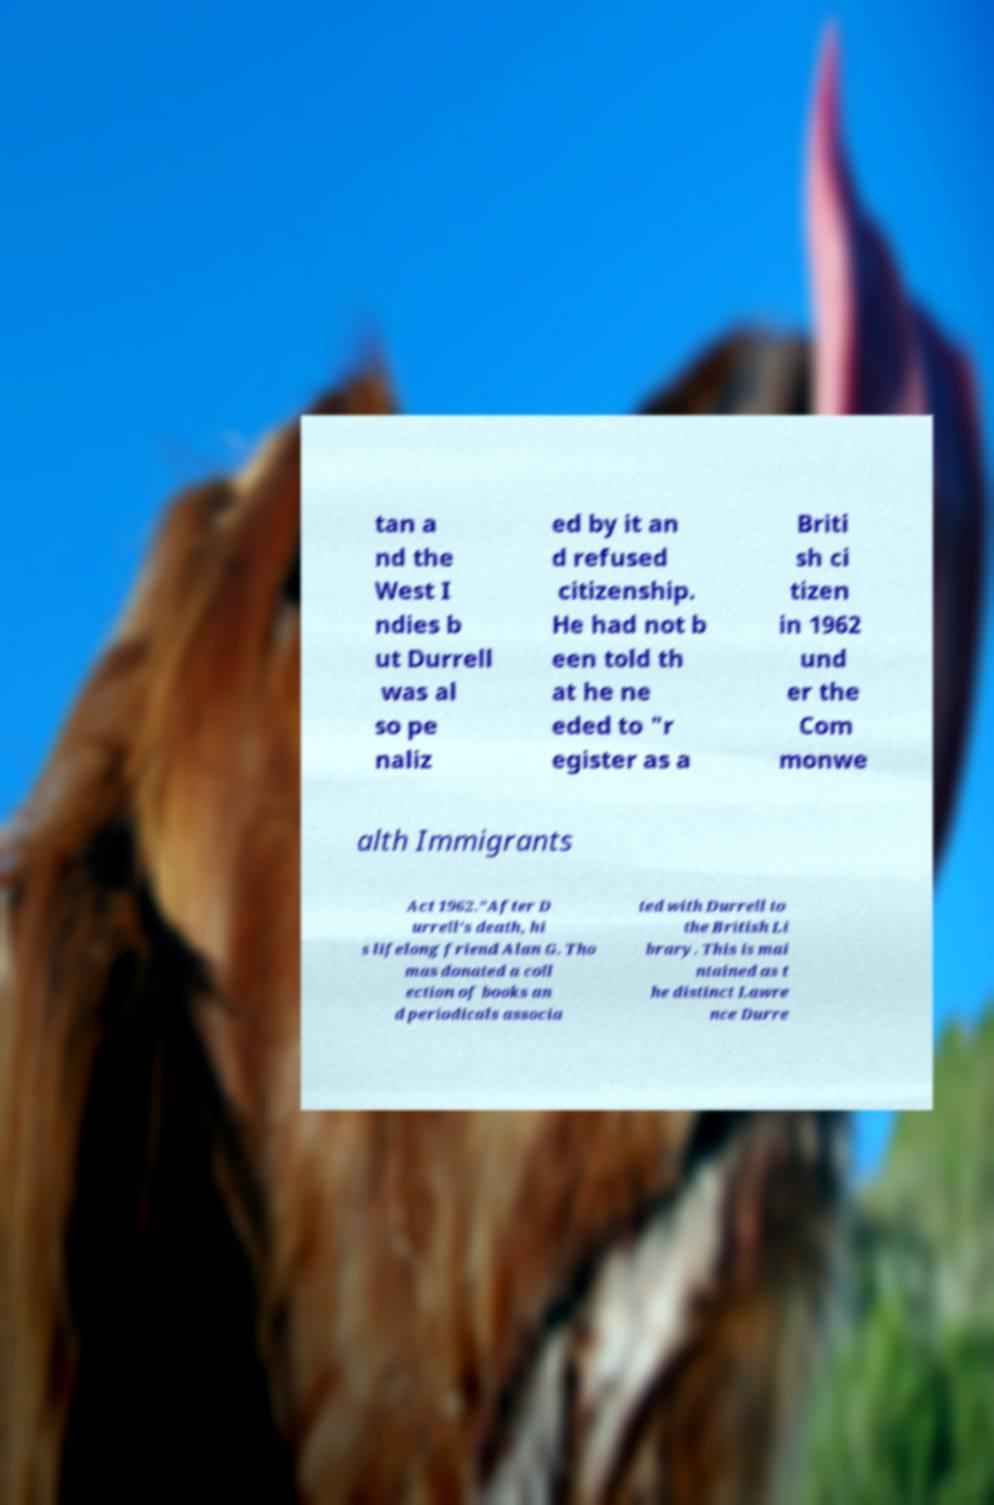For documentation purposes, I need the text within this image transcribed. Could you provide that? tan a nd the West I ndies b ut Durrell was al so pe naliz ed by it an d refused citizenship. He had not b een told th at he ne eded to "r egister as a Briti sh ci tizen in 1962 und er the Com monwe alth Immigrants Act 1962."After D urrell's death, hi s lifelong friend Alan G. Tho mas donated a coll ection of books an d periodicals associa ted with Durrell to the British Li brary. This is mai ntained as t he distinct Lawre nce Durre 